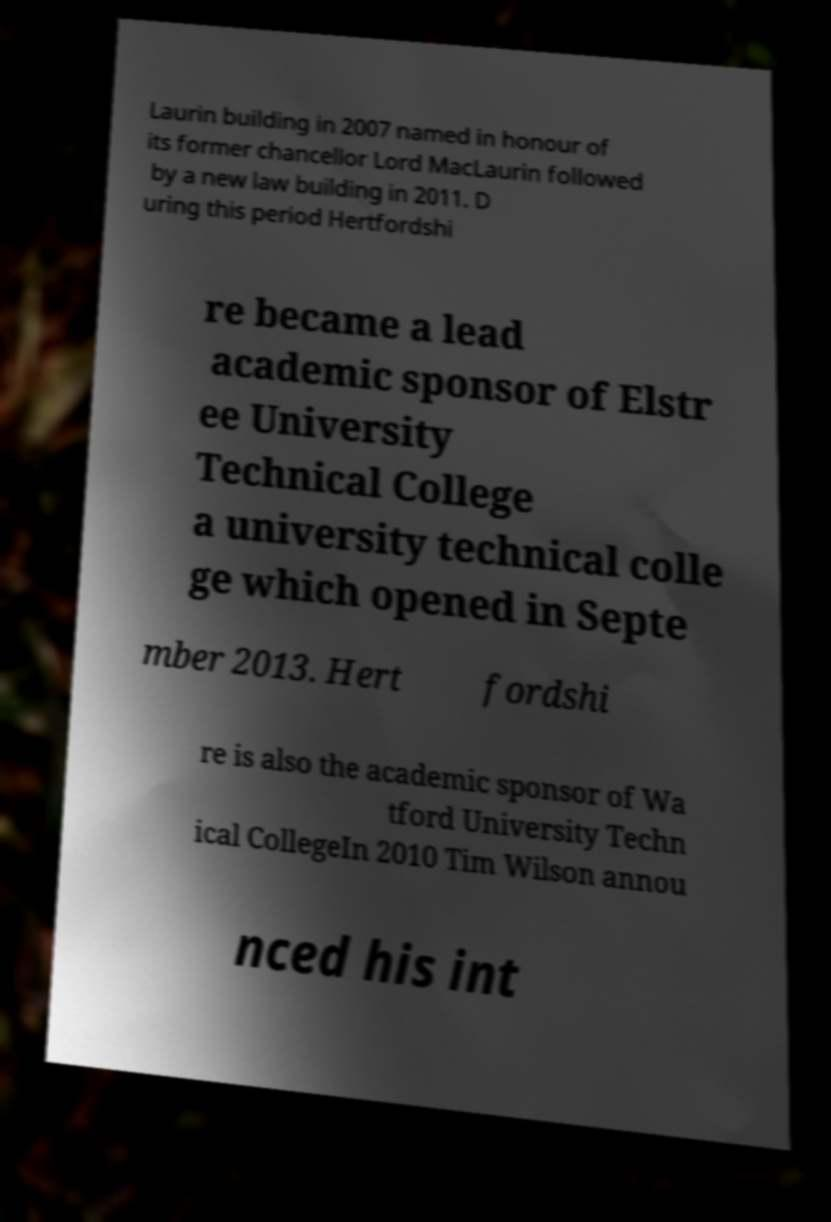For documentation purposes, I need the text within this image transcribed. Could you provide that? Laurin building in 2007 named in honour of its former chancellor Lord MacLaurin followed by a new law building in 2011. D uring this period Hertfordshi re became a lead academic sponsor of Elstr ee University Technical College a university technical colle ge which opened in Septe mber 2013. Hert fordshi re is also the academic sponsor of Wa tford University Techn ical CollegeIn 2010 Tim Wilson annou nced his int 